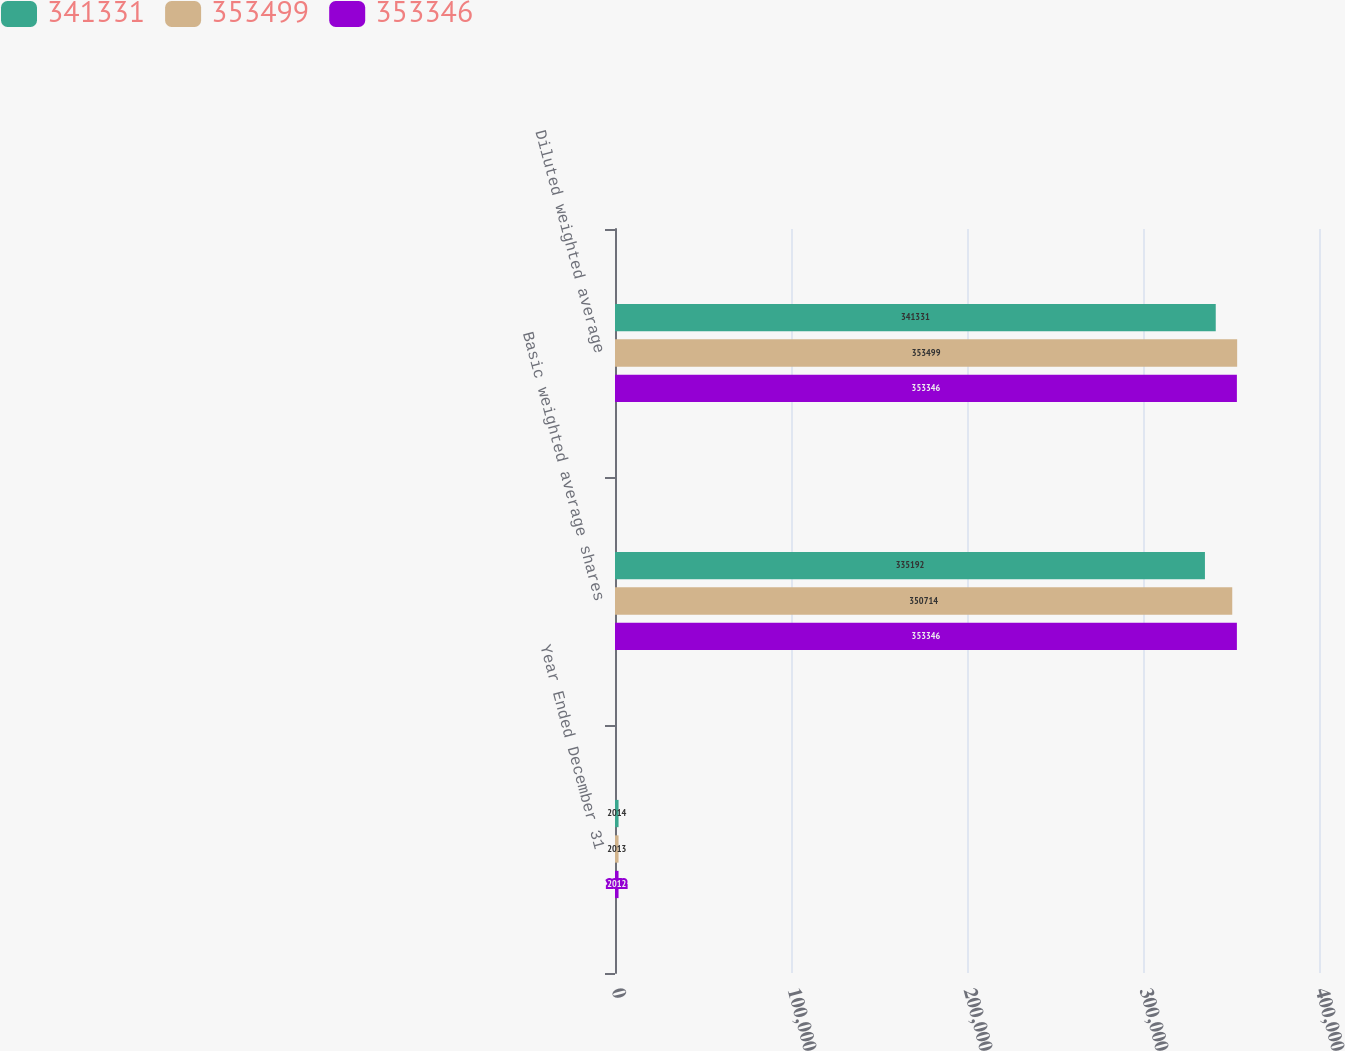Convert chart to OTSL. <chart><loc_0><loc_0><loc_500><loc_500><stacked_bar_chart><ecel><fcel>Year Ended December 31<fcel>Basic weighted average shares<fcel>Diluted weighted average<nl><fcel>341331<fcel>2014<fcel>335192<fcel>341331<nl><fcel>353499<fcel>2013<fcel>350714<fcel>353499<nl><fcel>353346<fcel>2012<fcel>353346<fcel>353346<nl></chart> 